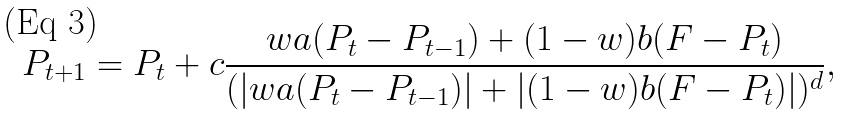<formula> <loc_0><loc_0><loc_500><loc_500>P _ { t + 1 } = P _ { t } + c \frac { w a ( P _ { t } - P _ { t - 1 } ) + ( 1 - w ) b ( F - P _ { t } ) } { ( | w a ( P _ { t } - P _ { t - 1 } ) | + | ( 1 - w ) b ( F - P _ { t } ) | ) ^ { d } } ,</formula> 